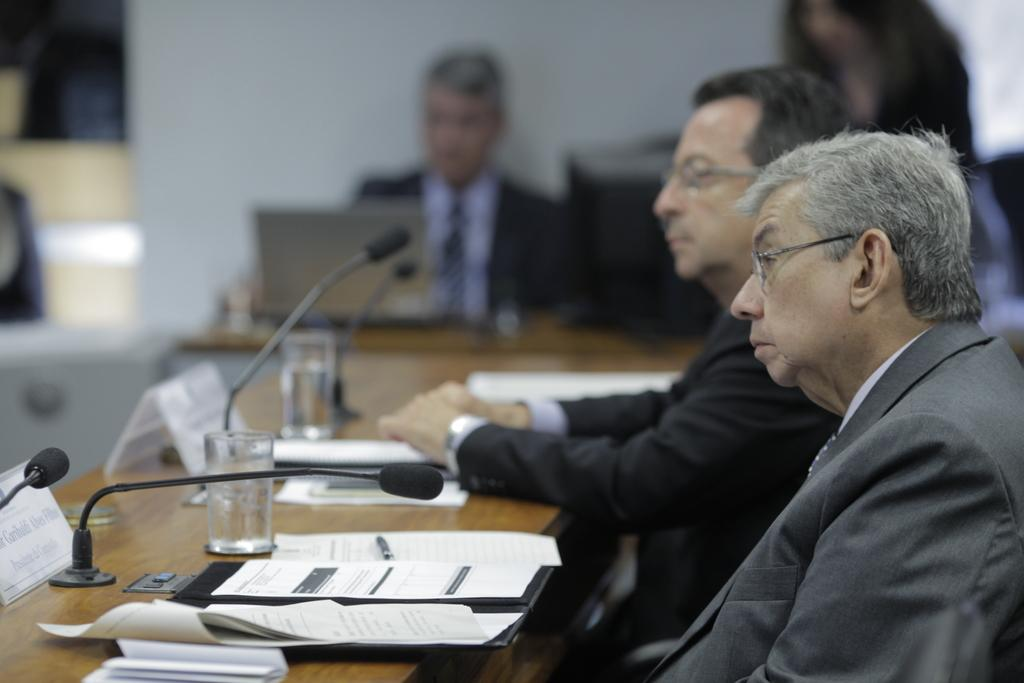What are the people in the image doing? The people in the image are sitting and talking. Where are the people located in relation to the table? The people are in front of a table. How are the people communicating with each other? The people are talking using a microphone. Is the queen present in the image? There is no queen present in the image. What attraction can be seen in the background of the image? There is no attraction visible in the image; it only shows people sitting in front of a table and talking using a microphone. 